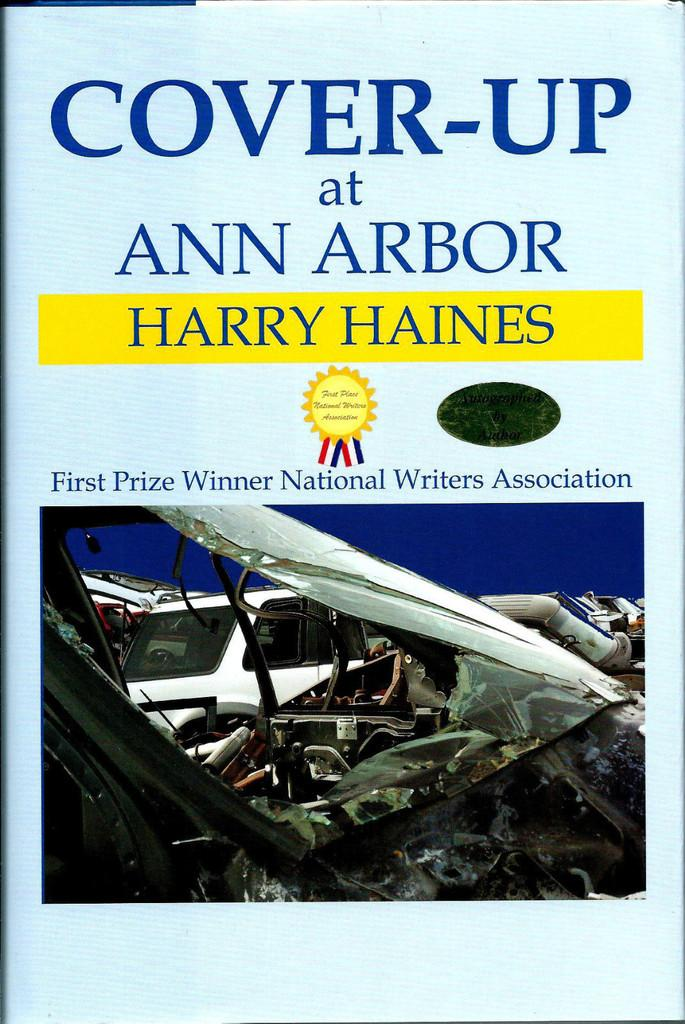<image>
Share a concise interpretation of the image provided. A book titled Cover-Up at Ann Arbor by Harry Haines was first place in the National Writers Association. 